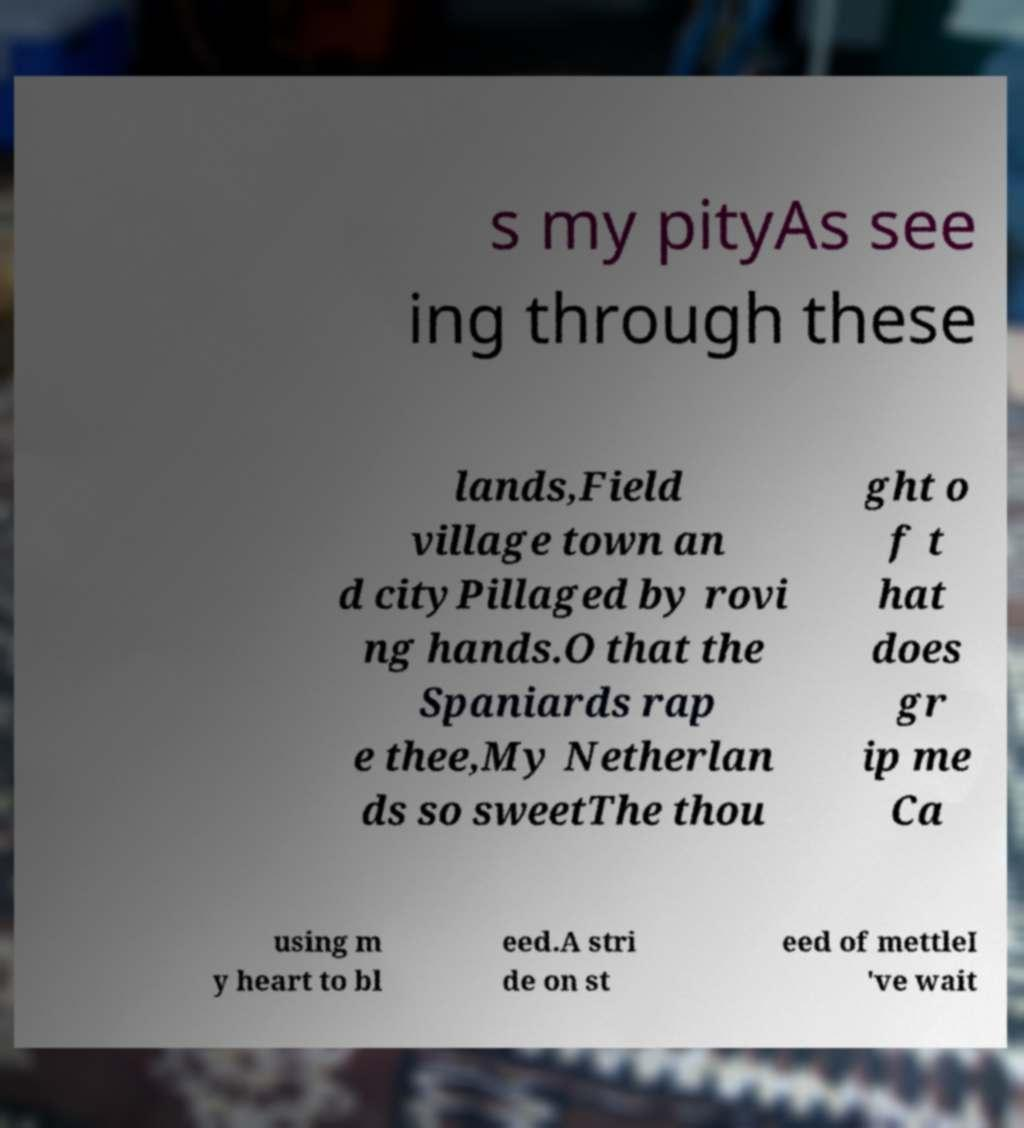Could you assist in decoding the text presented in this image and type it out clearly? s my pityAs see ing through these lands,Field village town an d cityPillaged by rovi ng hands.O that the Spaniards rap e thee,My Netherlan ds so sweetThe thou ght o f t hat does gr ip me Ca using m y heart to bl eed.A stri de on st eed of mettleI 've wait 